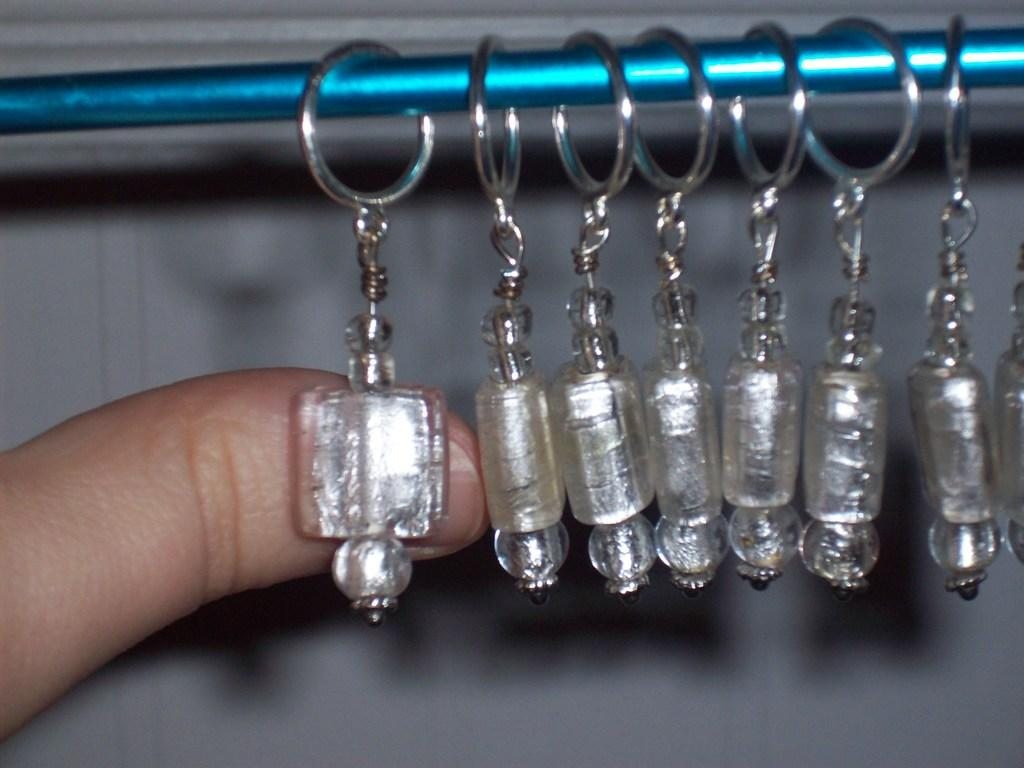What object is present in the image that can be used to hold keys? There is a key chain in the image. What body part of a person is visible in the image? A person's thumb is visible in the image. What can be seen in the background of the image? There is a wall in the background of the image. What type of root can be seen growing on the wall in the image? There is no root visible in the image; only a wall is present in the background. 